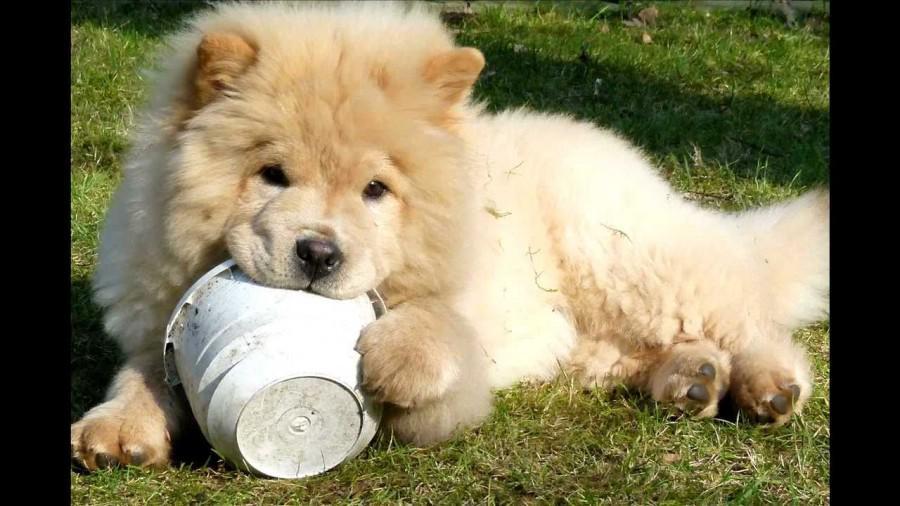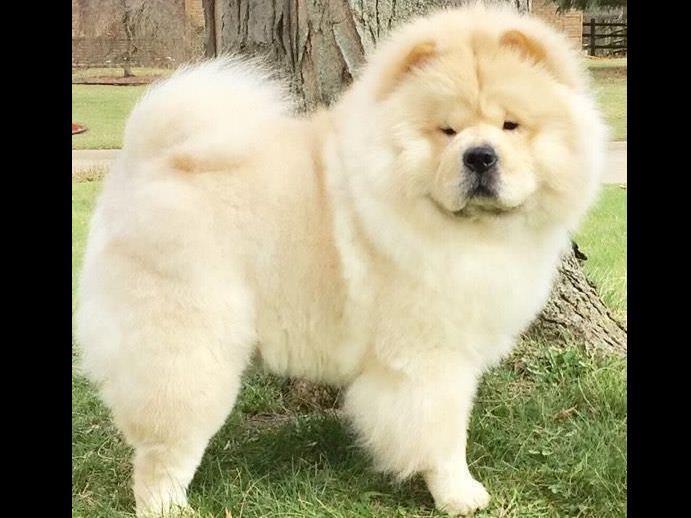The first image is the image on the left, the second image is the image on the right. For the images displayed, is the sentence "An image shows one cream-colored chow in a non-standing pose on the grass." factually correct? Answer yes or no. Yes. The first image is the image on the left, the second image is the image on the right. Analyze the images presented: Is the assertion "There are two dogs, and neither of them has anything in their mouth." valid? Answer yes or no. No. 